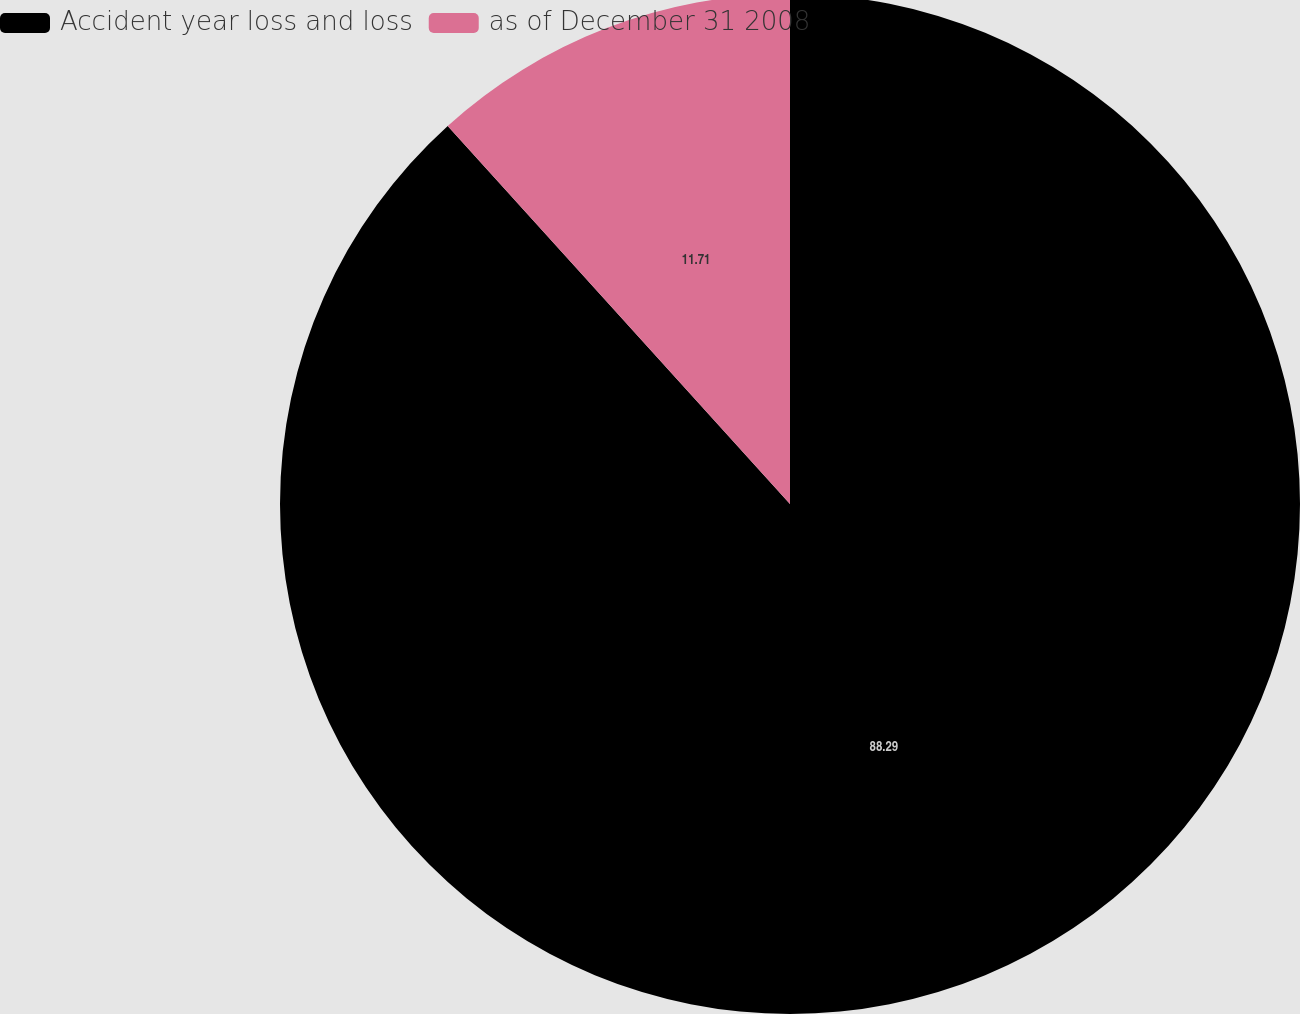<chart> <loc_0><loc_0><loc_500><loc_500><pie_chart><fcel>Accident year loss and loss<fcel>as of December 31 2008<nl><fcel>88.29%<fcel>11.71%<nl></chart> 